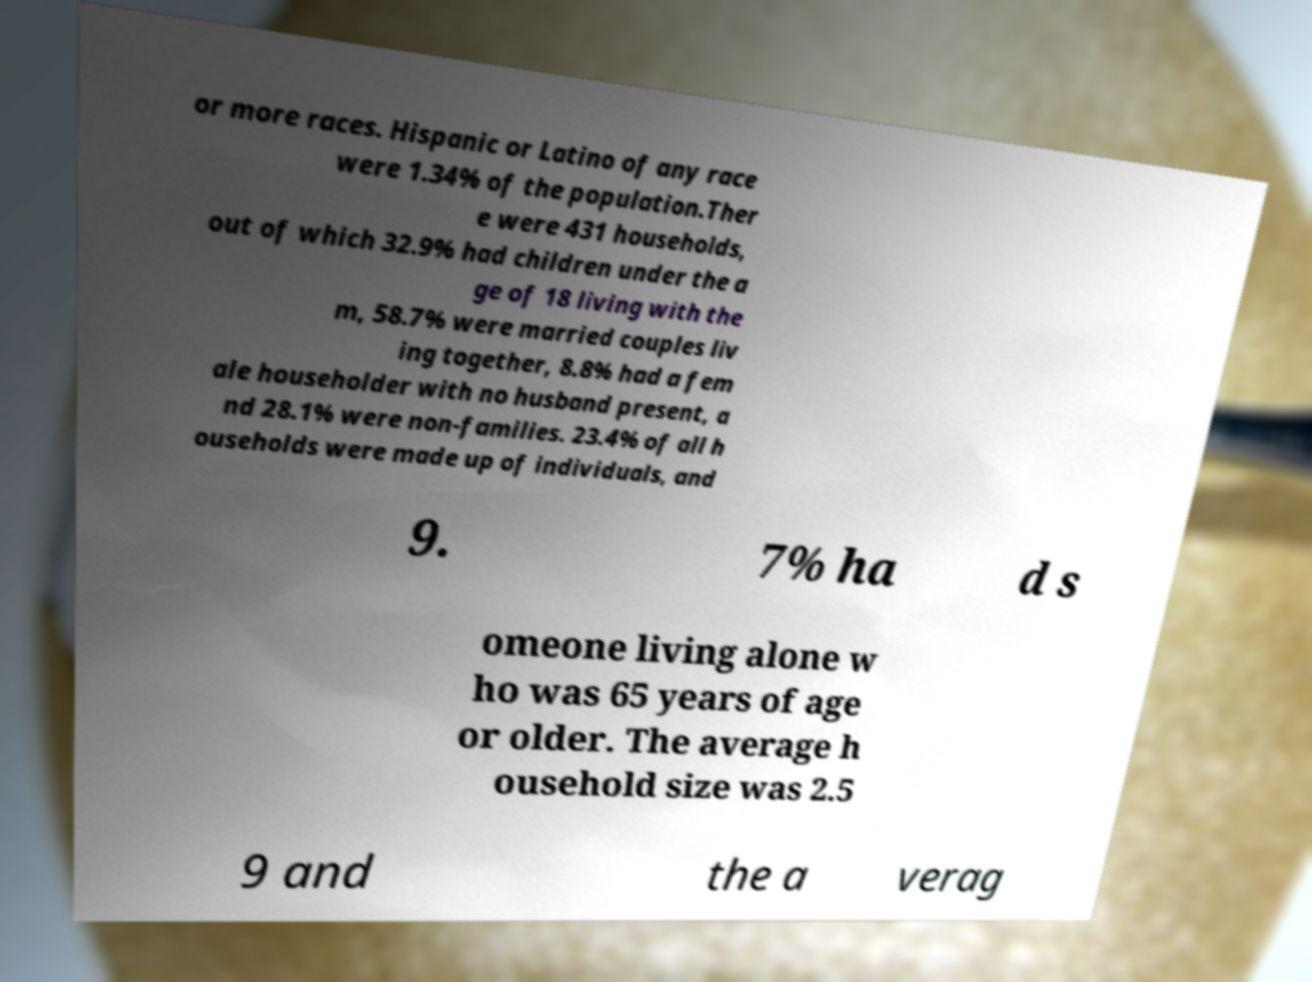Can you read and provide the text displayed in the image?This photo seems to have some interesting text. Can you extract and type it out for me? or more races. Hispanic or Latino of any race were 1.34% of the population.Ther e were 431 households, out of which 32.9% had children under the a ge of 18 living with the m, 58.7% were married couples liv ing together, 8.8% had a fem ale householder with no husband present, a nd 28.1% were non-families. 23.4% of all h ouseholds were made up of individuals, and 9. 7% ha d s omeone living alone w ho was 65 years of age or older. The average h ousehold size was 2.5 9 and the a verag 